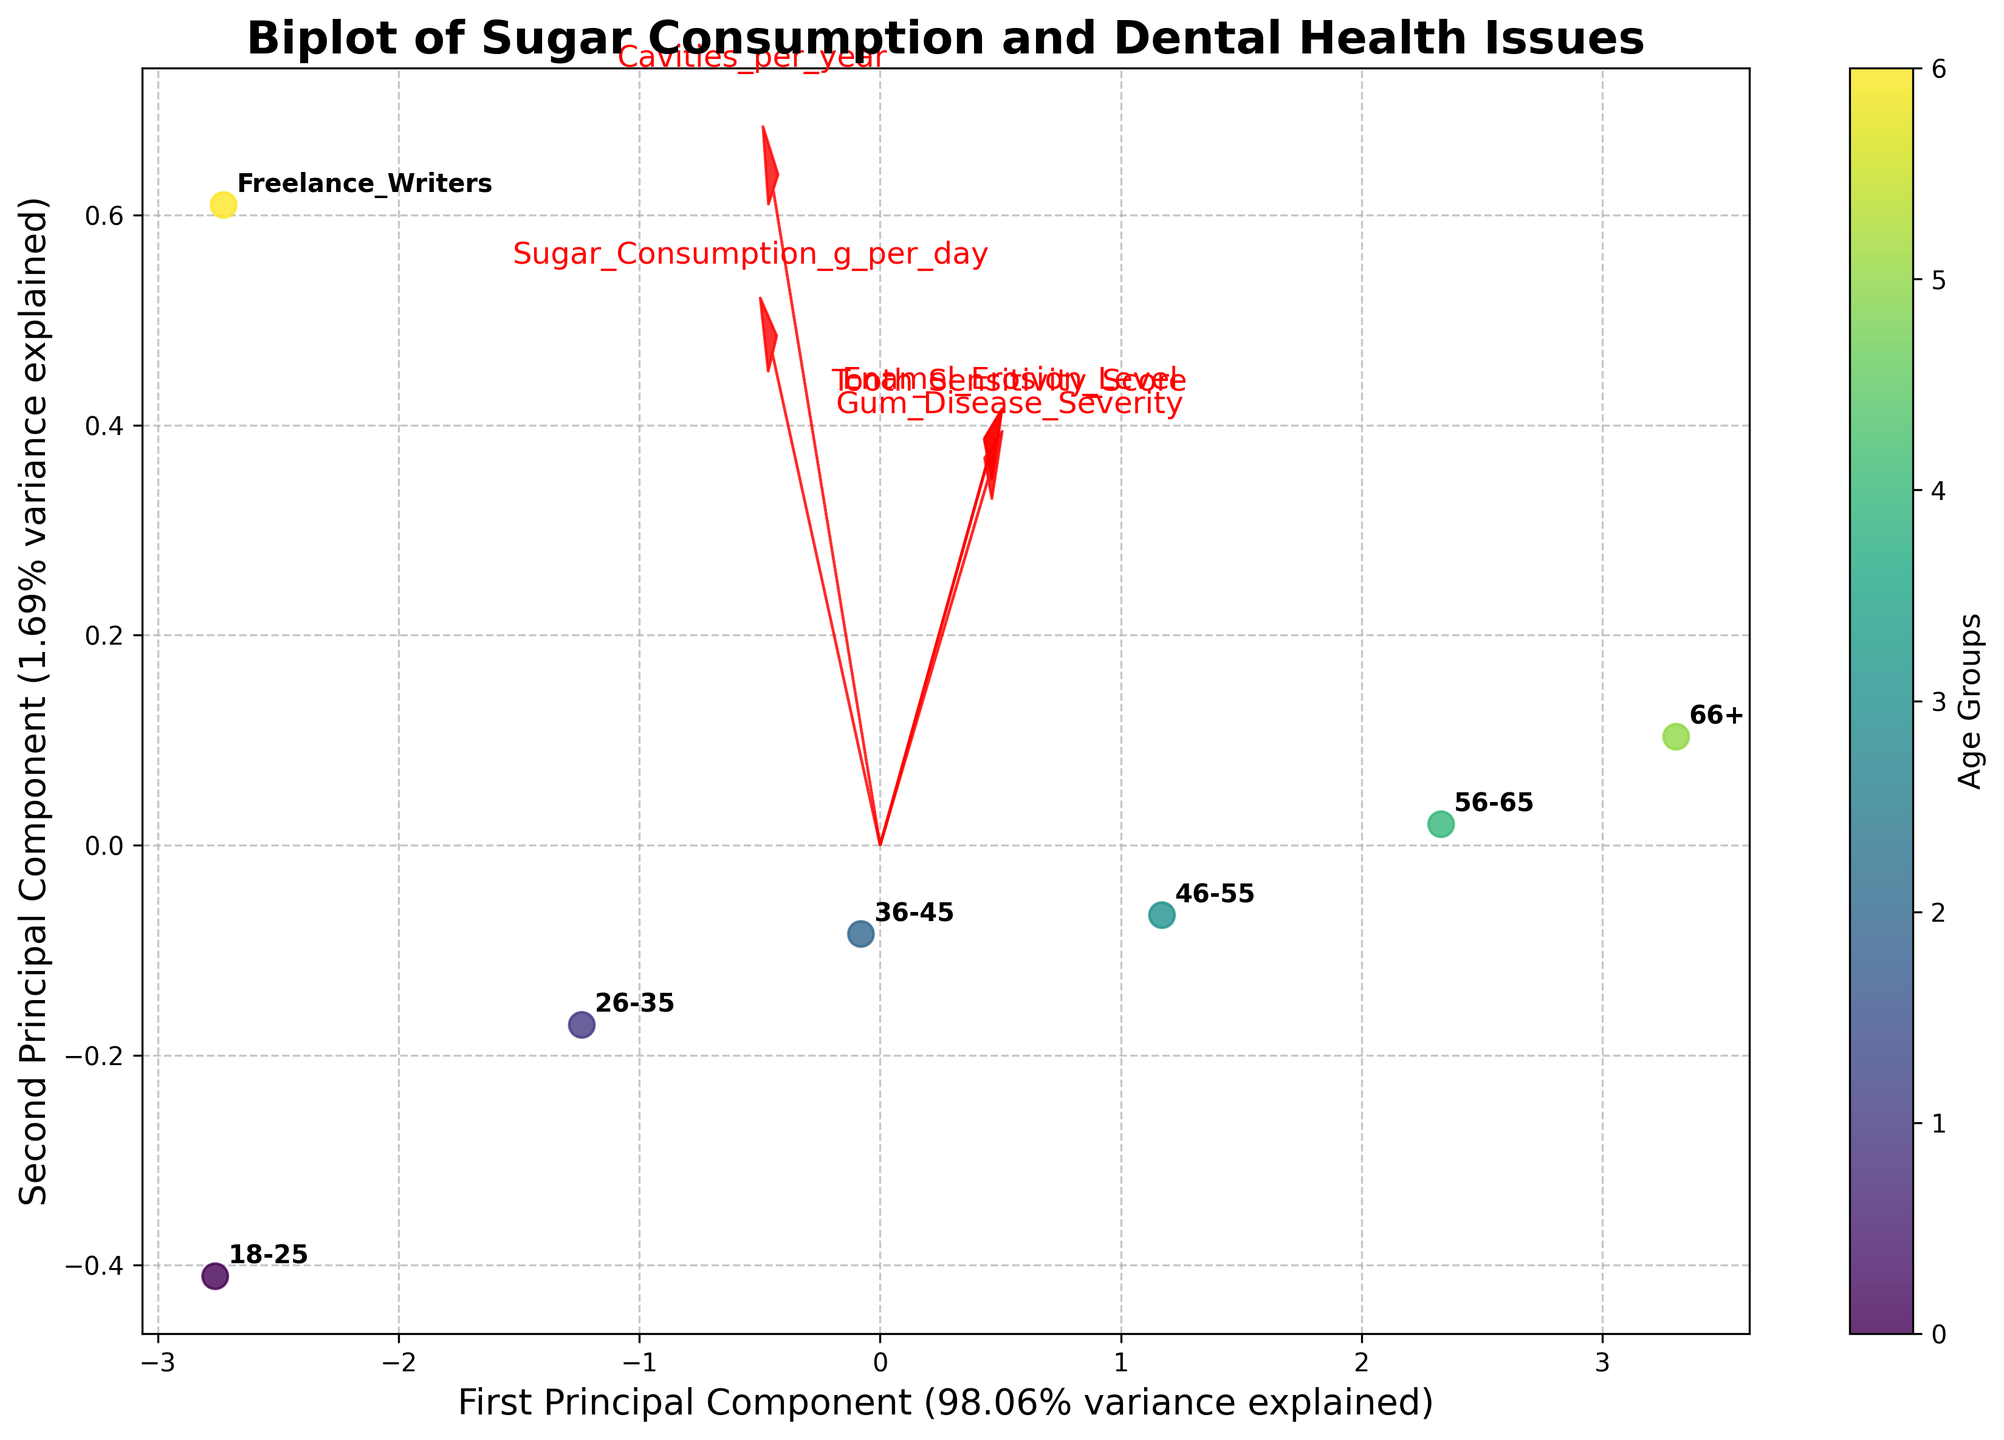What is the title of the figure? The title is found at the top of the plot. It is a textual label that summarizes the main topic of the plot.
Answer: Biplot of Sugar Consumption and Dental Health Issues How many age groups are represented in the biplot? Look at the number of unique labels next to the scatter plot points. Each label corresponds to an age group.
Answer: 7 Which age group has the highest sugar consumption according to the biplot? Identify the data point with the highest score on the 'Sugar_Consumption_g_per_day' axis, indicated by the direction and length of the feature arrow. Find the corresponding label.
Answer: Freelance Writers Which age group has the highest severity of gum disease? Identify the direction of the 'Gum_Disease_Severity' feature arrow. The point furthest in this direction corresponds to the highest severity.
Answer: 66+ What is the explained variance of the first principal component? Look at the label on the x-axis, which indicates the variance explained by the first principal component in percentage terms.
Answer: 40% What age group has a score closest to the origin (0,0) in the biplot? Determine which labeled data point is nearest to the origin (0,0) on the x and y axes.
Answer: 36-45 Between the age groups 18-25 and 56-65, which one has higher tooth sensitivity scores? Compare the positions of the data points for 18-25 and 56-65 in the direction of the 'Tooth_Sensitivity_Score' feature arrow. Higher scores are in the same direction as the arrow's endpoint.
Answer: 56-65 How does the 'Cavities_per_year' feature relate to the 'Sugar_Consumption_g_per_day' feature? Look at the arrows for both features. If they are pointing in similar or the same direction, it indicates a positive correlation. If they point in opposite directions, it indicates a negative correlation.
Answer: Positive correlation Which age group has the lowest enamel erosion level? Identify the direction of the 'Enamel_Erosion_Level' feature arrow. The point furthest in the opposite direction corresponds to the lowest erosion level.
Answer: 18-25 